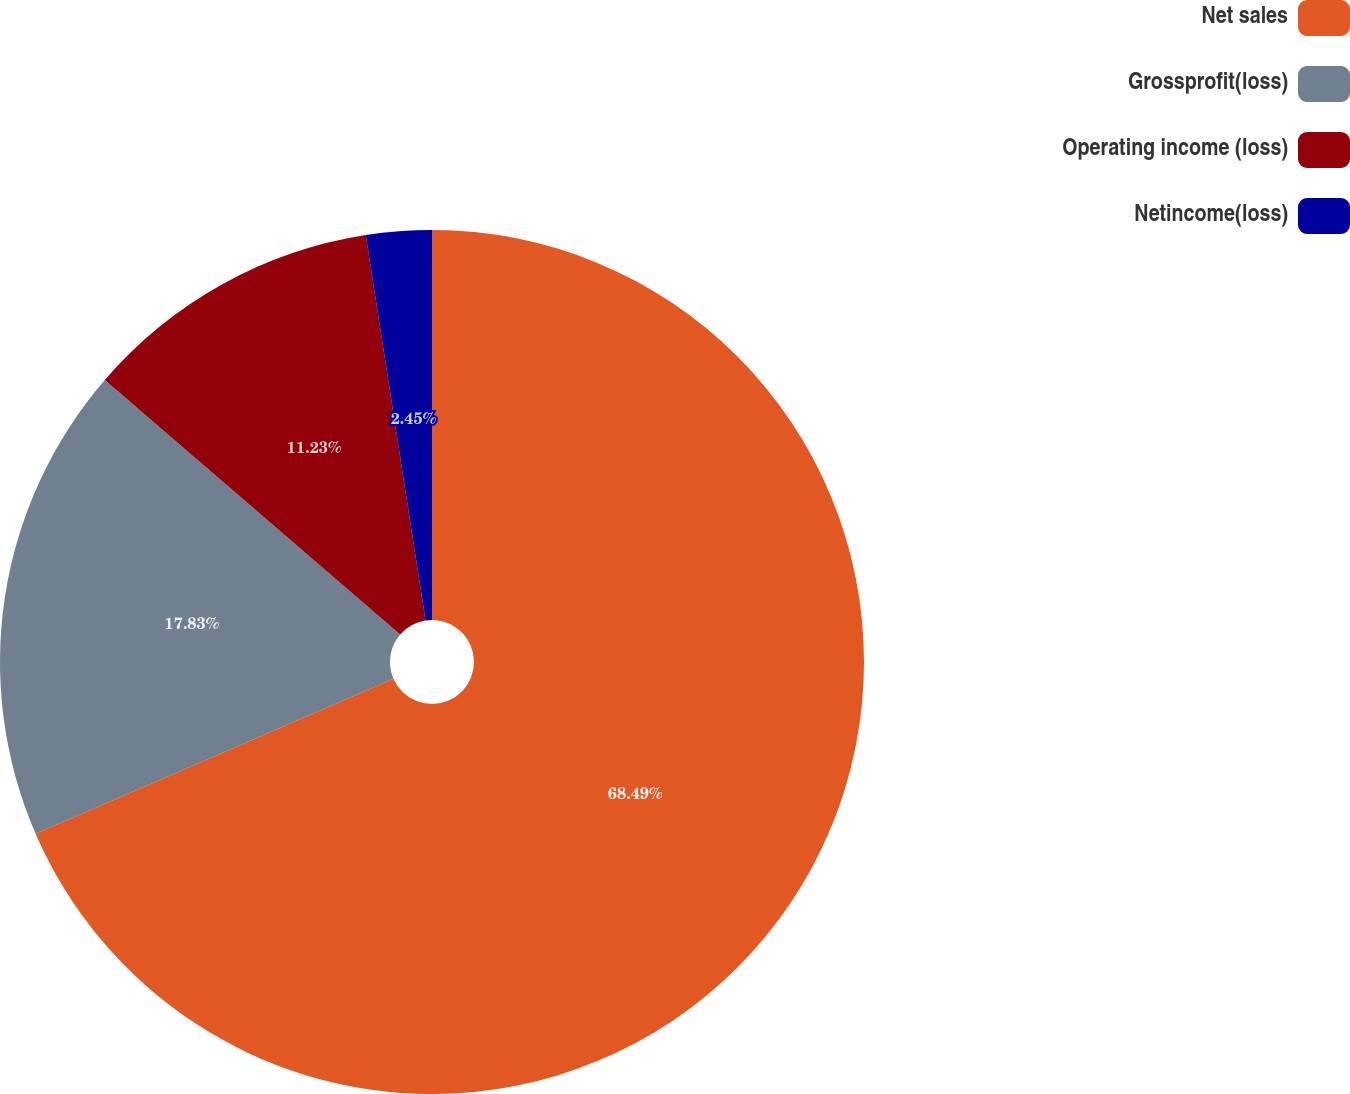<chart> <loc_0><loc_0><loc_500><loc_500><pie_chart><fcel>Net sales<fcel>Grossprofit(loss)<fcel>Operating income (loss)<fcel>Netincome(loss)<nl><fcel>68.5%<fcel>17.83%<fcel>11.23%<fcel>2.45%<nl></chart> 